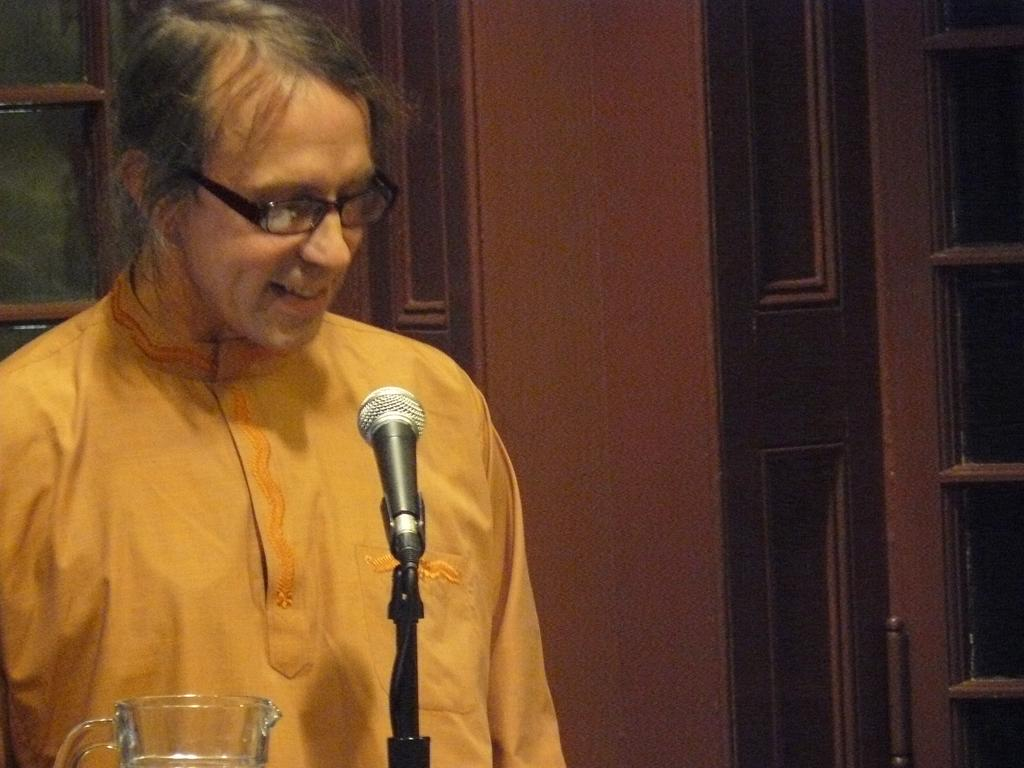What is the person in the image doing? The person is standing in the image and holding a mic. What is in front of the person? There is a jar in front of the person. What can be seen in the background of the image? There is a window and a door in the background of the image. How many snails are crawling on the person's hand in the image? There are no snails present in the image. What type of nail is being used by the person in the image? The person is holding a mic, not a nail, in the image. 